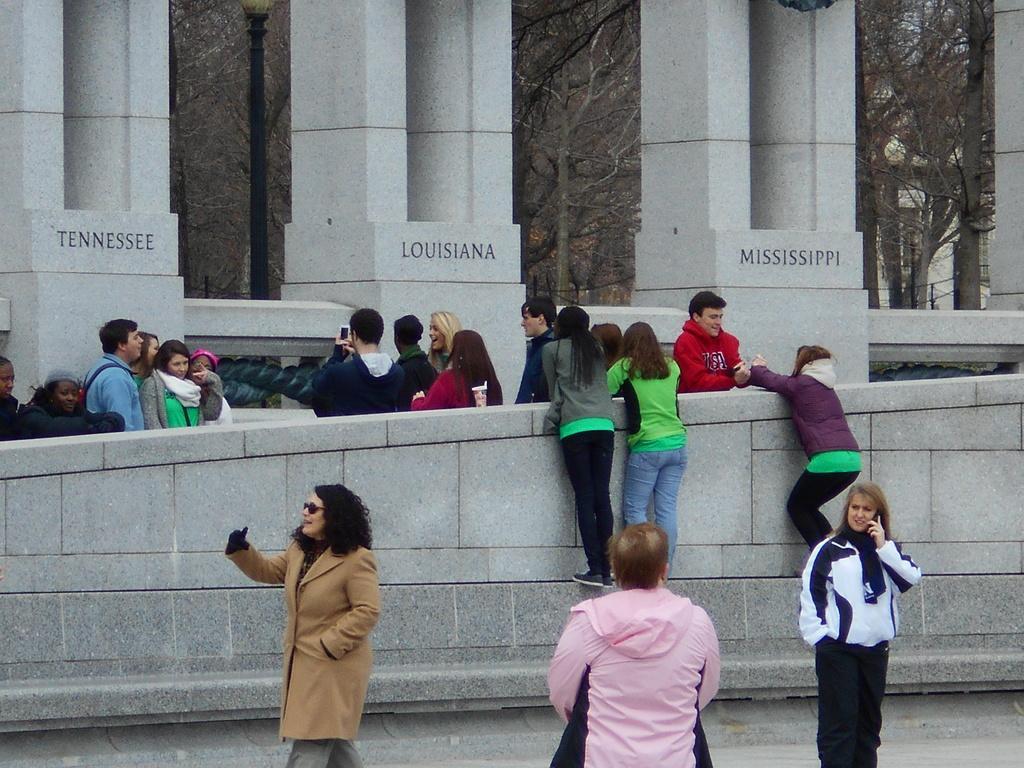How would you summarize this image in a sentence or two? In this image I can see the group of people with different color dresses. I can see one person with the goggles. To the side of these people I can see the pillars and the names written on the pillars. There are many trees in the back. 